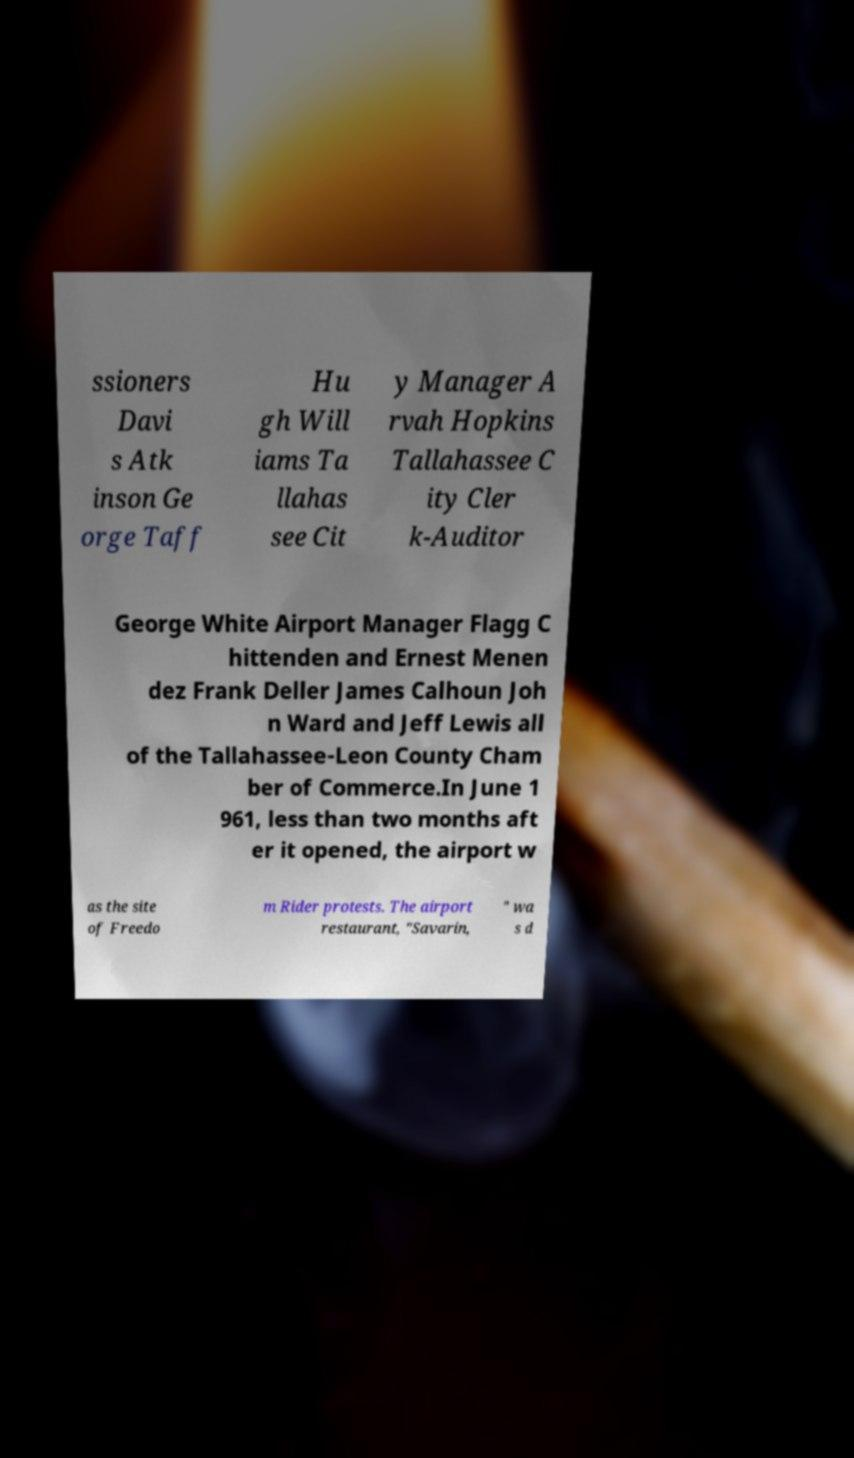Could you assist in decoding the text presented in this image and type it out clearly? ssioners Davi s Atk inson Ge orge Taff Hu gh Will iams Ta llahas see Cit y Manager A rvah Hopkins Tallahassee C ity Cler k-Auditor George White Airport Manager Flagg C hittenden and Ernest Menen dez Frank Deller James Calhoun Joh n Ward and Jeff Lewis all of the Tallahassee-Leon County Cham ber of Commerce.In June 1 961, less than two months aft er it opened, the airport w as the site of Freedo m Rider protests. The airport restaurant, "Savarin, " wa s d 